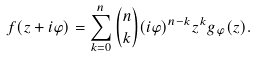<formula> <loc_0><loc_0><loc_500><loc_500>f ( z + i \varphi ) = \sum _ { k = 0 } ^ { n } \binom { n } { k } ( i \varphi ) ^ { n - k } z ^ { k } g _ { \varphi } ( z ) .</formula> 